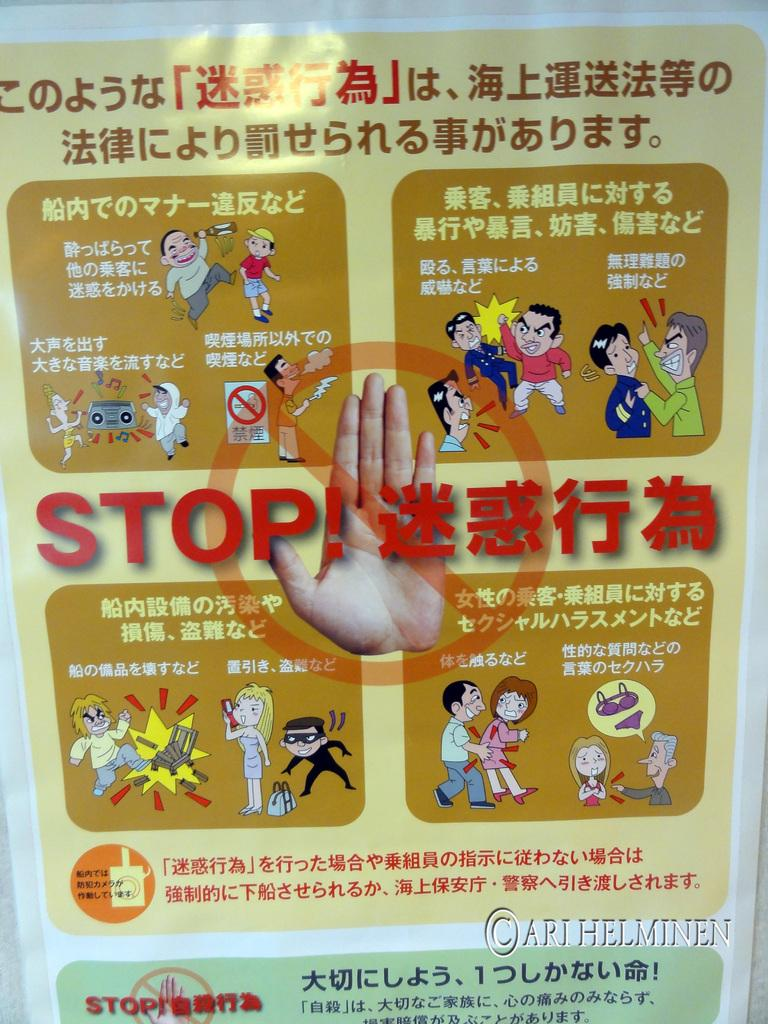What is present on the poster in the image? The poster contains text and cartoon images. Can you describe the poster's content in more detail? The poster contains text and cartoon images, as well as a person's hand. What type of images are depicted on the poster? The images on the poster are cartoon images. What type of road can be seen in the image? There is no road present in the image; it features a poster with text and cartoon images. How many cans are visible in the image? There are no cans present in the image. 